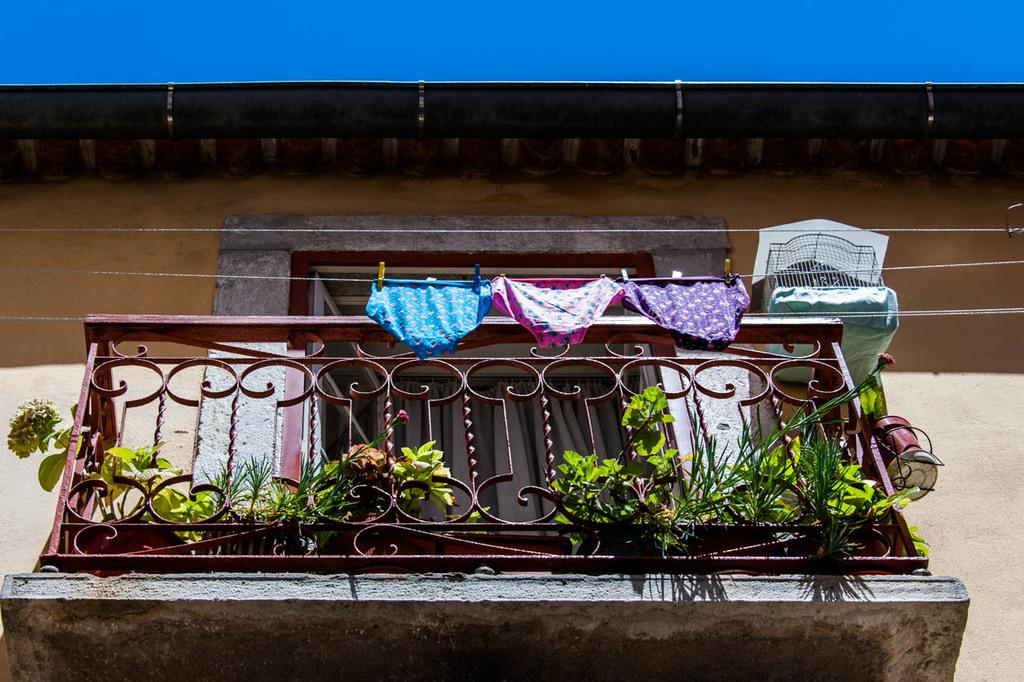What type of structure is present in the image? There is a balcony in the image. To which structure does the balcony belong? The balcony belongs to a building. What feature can be seen on the balcony? The balcony has a fence. What is located in front of the balcony? There are plants in front of the balcony. What can be seen beside the balcony? There are inner wear attached to a rope beside the balcony. What type of cake is being served on the balcony in the image? There is no cake present in the image; it features a balcony with a fence, plants, and inner wear attached to a rope. 